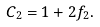Convert formula to latex. <formula><loc_0><loc_0><loc_500><loc_500>C _ { 2 } = 1 + 2 f _ { 2 } .</formula> 